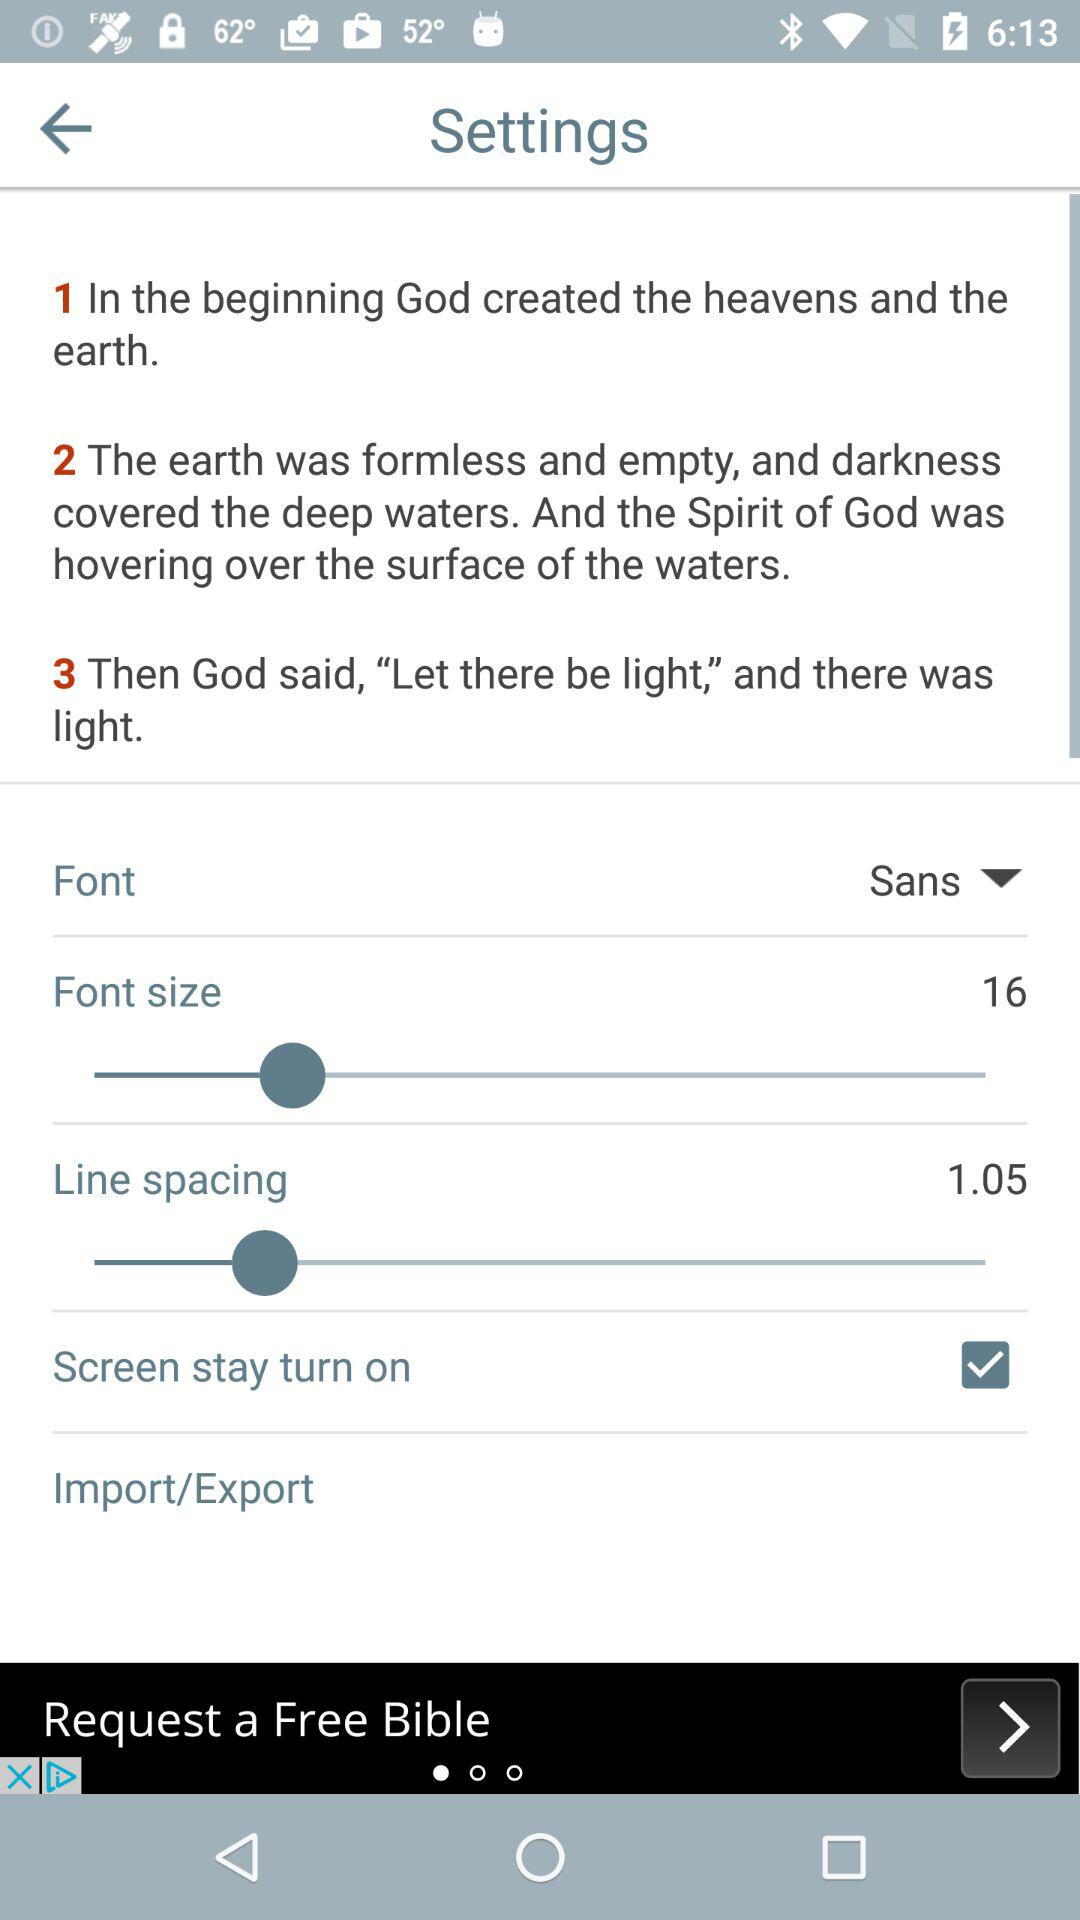What is the font size? The font size is 16. 